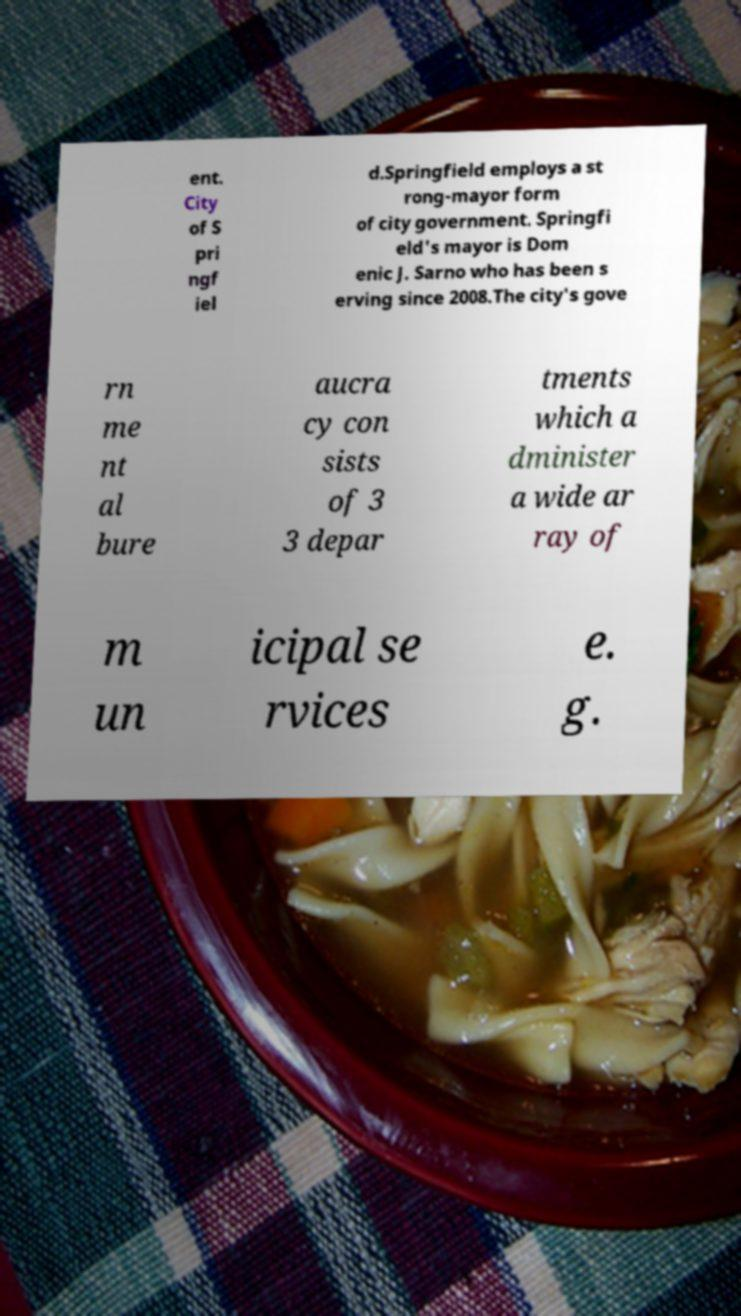Please read and relay the text visible in this image. What does it say? ent. City of S pri ngf iel d.Springfield employs a st rong-mayor form of city government. Springfi eld's mayor is Dom enic J. Sarno who has been s erving since 2008.The city's gove rn me nt al bure aucra cy con sists of 3 3 depar tments which a dminister a wide ar ray of m un icipal se rvices e. g. 